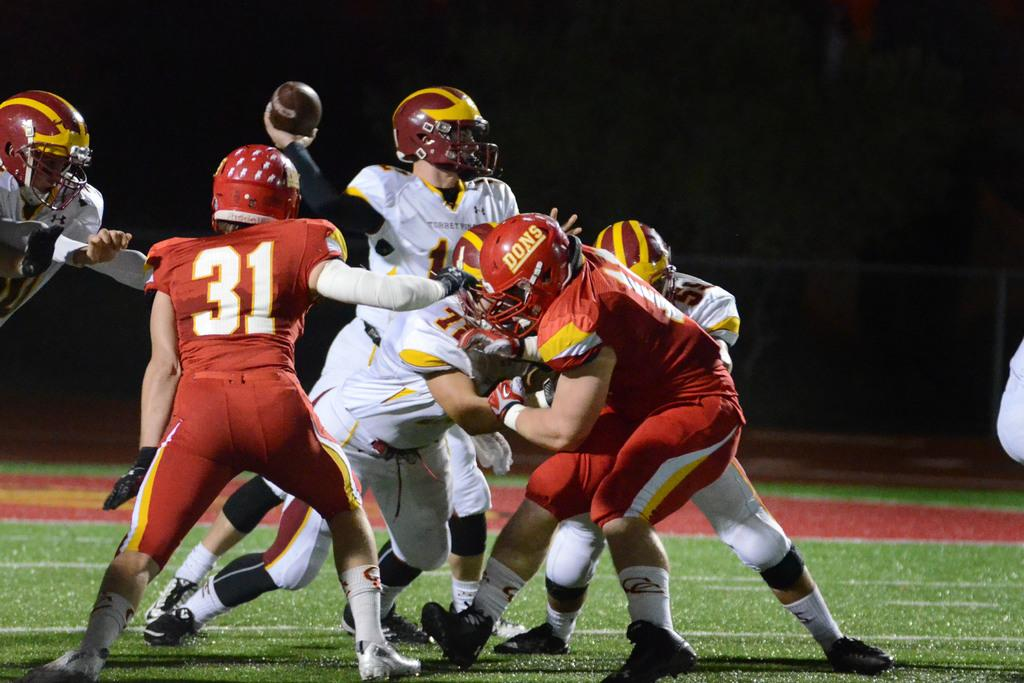What type of people are in the image? There are sports persons in the image. What are the sports persons doing in the image? The sports persons are playing on the ground. What type of surface can be seen at the bottom of the image? There is grass visible at the bottom of the image. How many words are written on the grass in the image? There are no words written on the grass in the image. What type of growth can be seen on the sports persons in the image? There is no growth visible on the sports persons in the image. 